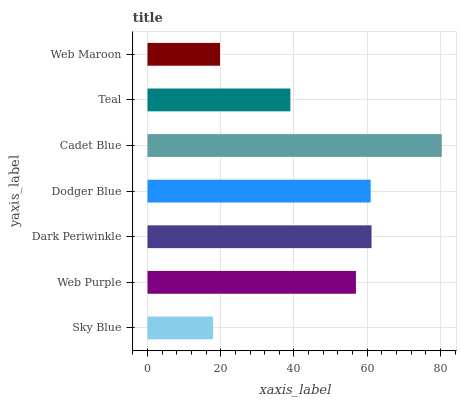Is Sky Blue the minimum?
Answer yes or no. Yes. Is Cadet Blue the maximum?
Answer yes or no. Yes. Is Web Purple the minimum?
Answer yes or no. No. Is Web Purple the maximum?
Answer yes or no. No. Is Web Purple greater than Sky Blue?
Answer yes or no. Yes. Is Sky Blue less than Web Purple?
Answer yes or no. Yes. Is Sky Blue greater than Web Purple?
Answer yes or no. No. Is Web Purple less than Sky Blue?
Answer yes or no. No. Is Web Purple the high median?
Answer yes or no. Yes. Is Web Purple the low median?
Answer yes or no. Yes. Is Dark Periwinkle the high median?
Answer yes or no. No. Is Sky Blue the low median?
Answer yes or no. No. 